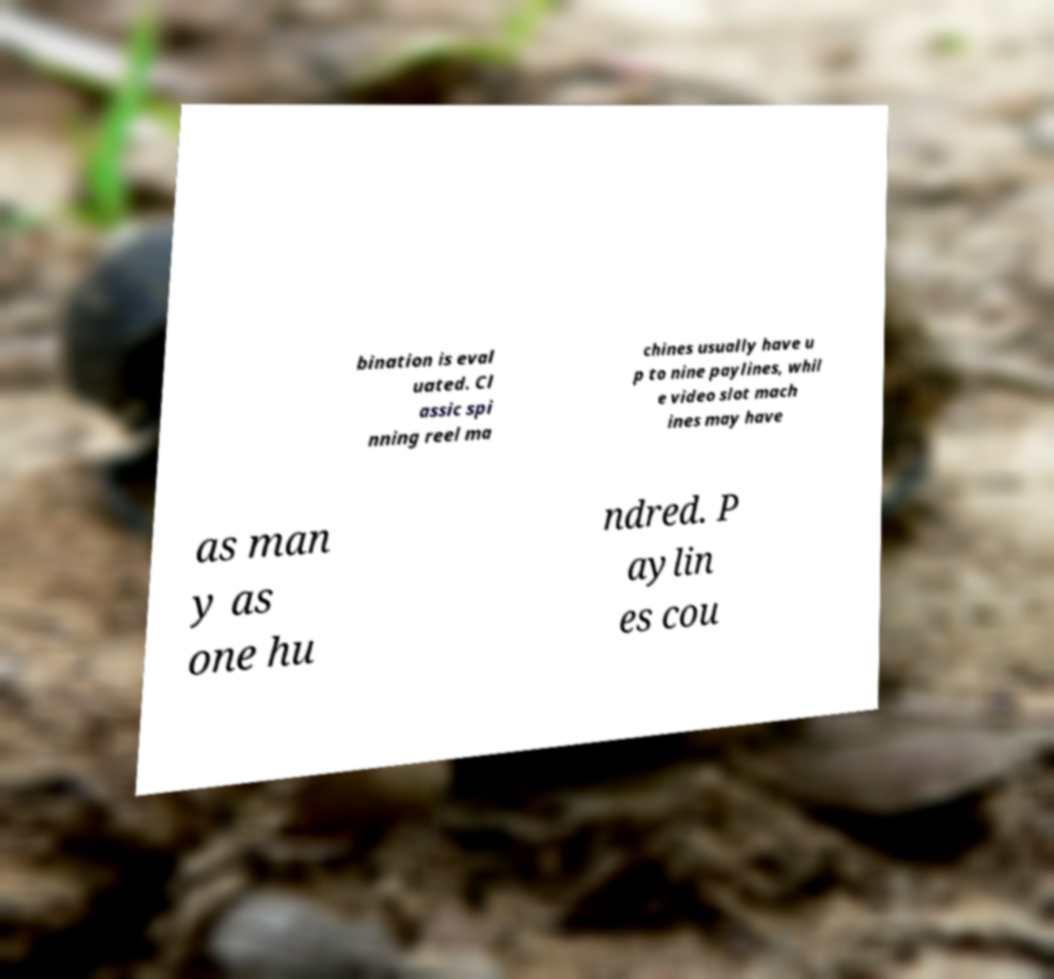For documentation purposes, I need the text within this image transcribed. Could you provide that? bination is eval uated. Cl assic spi nning reel ma chines usually have u p to nine paylines, whil e video slot mach ines may have as man y as one hu ndred. P aylin es cou 